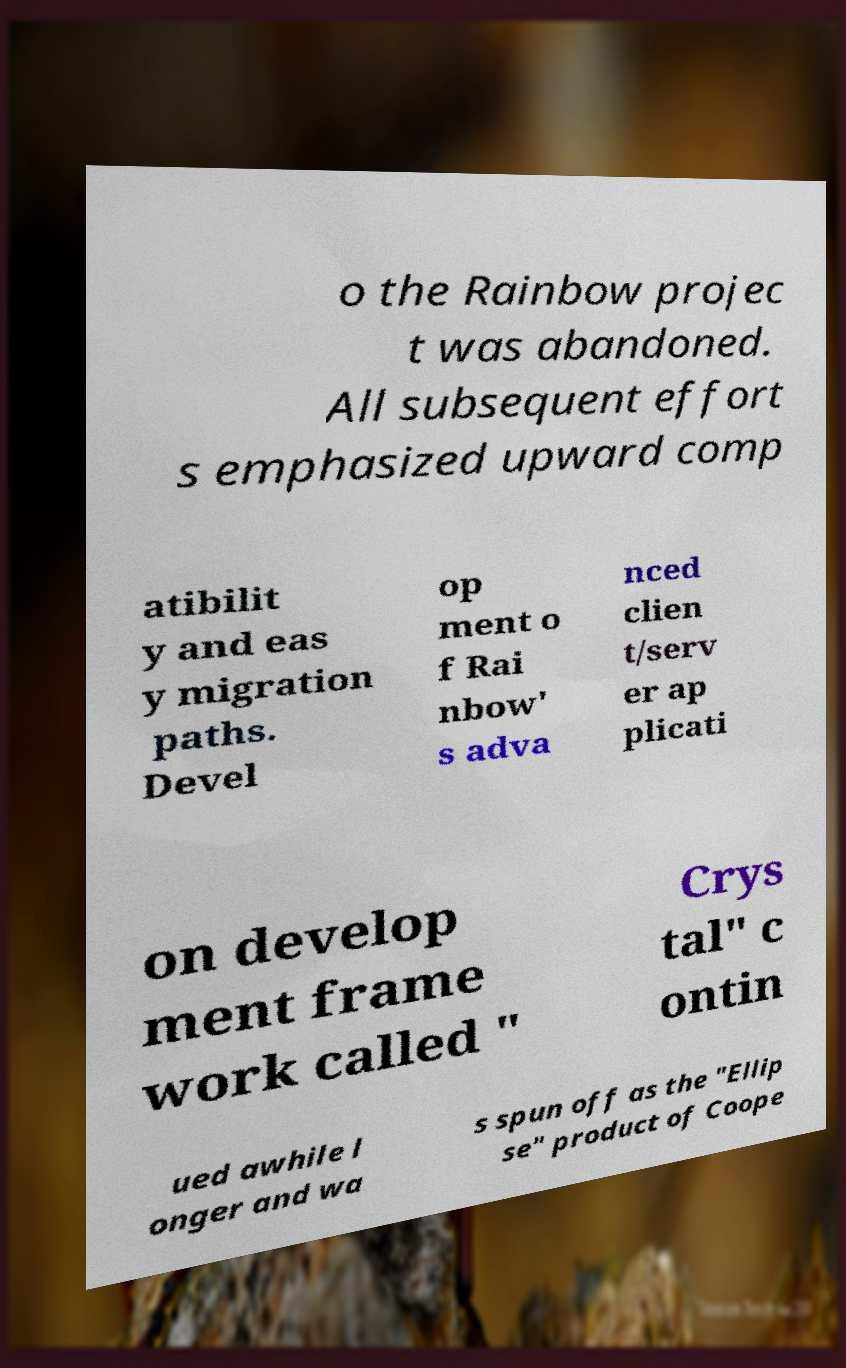Please read and relay the text visible in this image. What does it say? o the Rainbow projec t was abandoned. All subsequent effort s emphasized upward comp atibilit y and eas y migration paths. Devel op ment o f Rai nbow' s adva nced clien t/serv er ap plicati on develop ment frame work called " Crys tal" c ontin ued awhile l onger and wa s spun off as the "Ellip se" product of Coope 